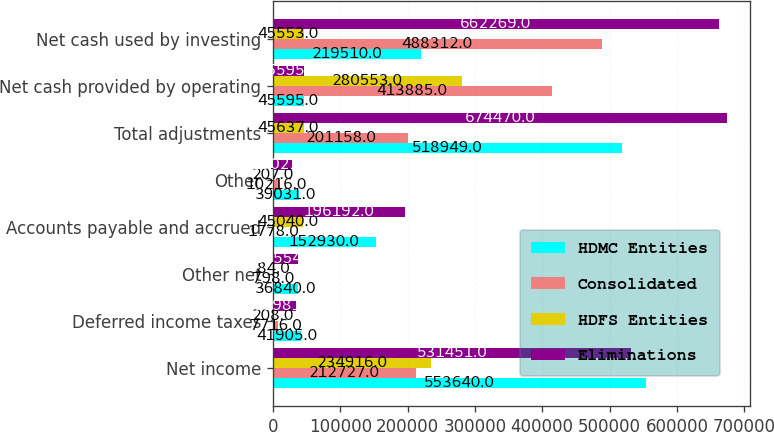Convert chart to OTSL. <chart><loc_0><loc_0><loc_500><loc_500><stacked_bar_chart><ecel><fcel>Net income<fcel>Deferred income taxes<fcel>Other net<fcel>Accounts payable and accrued<fcel>Other<fcel>Total adjustments<fcel>Net cash provided by operating<fcel>Net cash used by investing<nl><fcel>HDMC Entities<fcel>553640<fcel>41905<fcel>36840<fcel>152930<fcel>39031<fcel>518949<fcel>45595<fcel>219510<nl><fcel>Consolidated<fcel>212727<fcel>7716<fcel>798<fcel>1778<fcel>10216<fcel>201158<fcel>413885<fcel>488312<nl><fcel>HDFS Entities<fcel>234916<fcel>208<fcel>84<fcel>45040<fcel>207<fcel>45637<fcel>280553<fcel>45553<nl><fcel>Eliminations<fcel>531451<fcel>33981<fcel>37554<fcel>196192<fcel>29022<fcel>674470<fcel>45595<fcel>662269<nl></chart> 